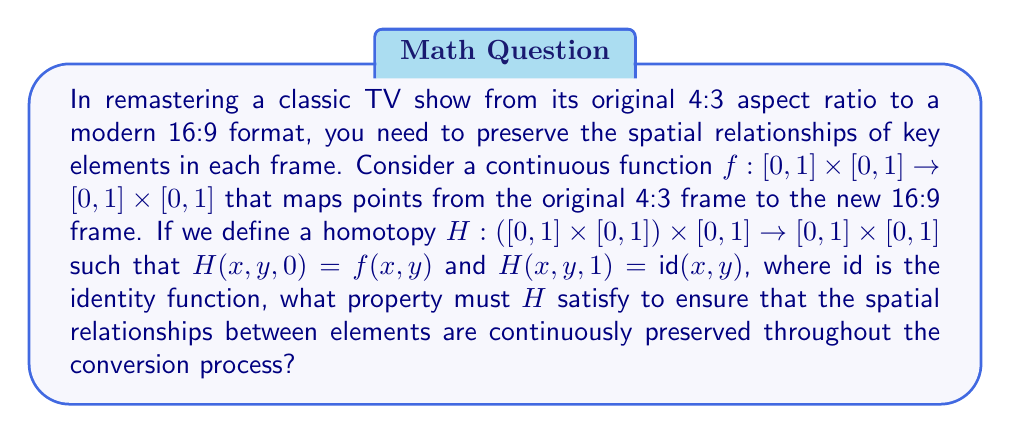Can you answer this question? To answer this question, we need to understand the concepts of homotopy theory and how they apply to aspect ratio conversion in TV show remastering.

1. First, let's interpret the given information:
   - $f : [0, 1] \times [0, 1] \rightarrow [0, 1] \times [0, 1]$ represents the mapping from the original 4:3 frame to the 16:9 frame.
   - $H : ([0, 1] \times [0, 1]) \times [0, 1] \rightarrow [0, 1] \times [0, 1]$ is a homotopy between $f$ and the identity function.

2. In homotopy theory, a homotopy is a continuous deformation between two continuous functions. In this case, we're deforming the aspect ratio conversion function $f$ to the identity function $\text{id}$.

3. To preserve spatial relationships, we need the homotopy to be continuous and bijective at every stage of the deformation. This ensures that no two points are mapped to the same location, and no "tearing" or "gluing" occurs during the transformation.

4. The property that ensures this is called a "isotopy". An isotopy is a homotopy where each intermediate function $H(\cdot, \cdot, t)$ is a homeomorphism for all $t \in [0, 1]$.

5. A homeomorphism is a continuous bijective function with a continuous inverse. This guarantees that the spatial relationships between elements are preserved at each stage of the conversion process.

6. Mathematically, for $H$ to be an isotopy, it must satisfy:
   - $H$ is continuous on $([0, 1] \times [0, 1]) \times [0, 1]$
   - For each $t \in [0, 1]$, the function $H_t(x, y) = H(x, y, t)$ is a homeomorphism from $[0, 1] \times [0, 1]$ to itself.

Therefore, the property that $H$ must satisfy to ensure continuous preservation of spatial relationships is that it must be an isotopy.
Answer: $H$ must be an isotopy. 